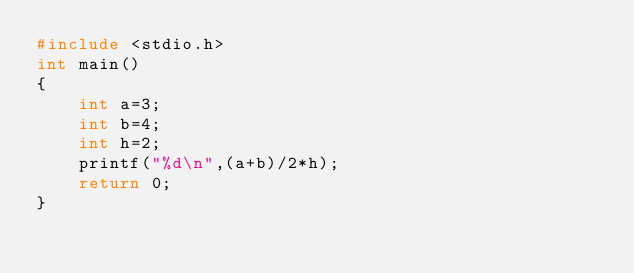<code> <loc_0><loc_0><loc_500><loc_500><_C_>#include <stdio.h>
int main()
{
    int a=3;
    int b=4;
    int h=2;
    printf("%d\n",(a+b)/2*h);
    return 0;
}</code> 